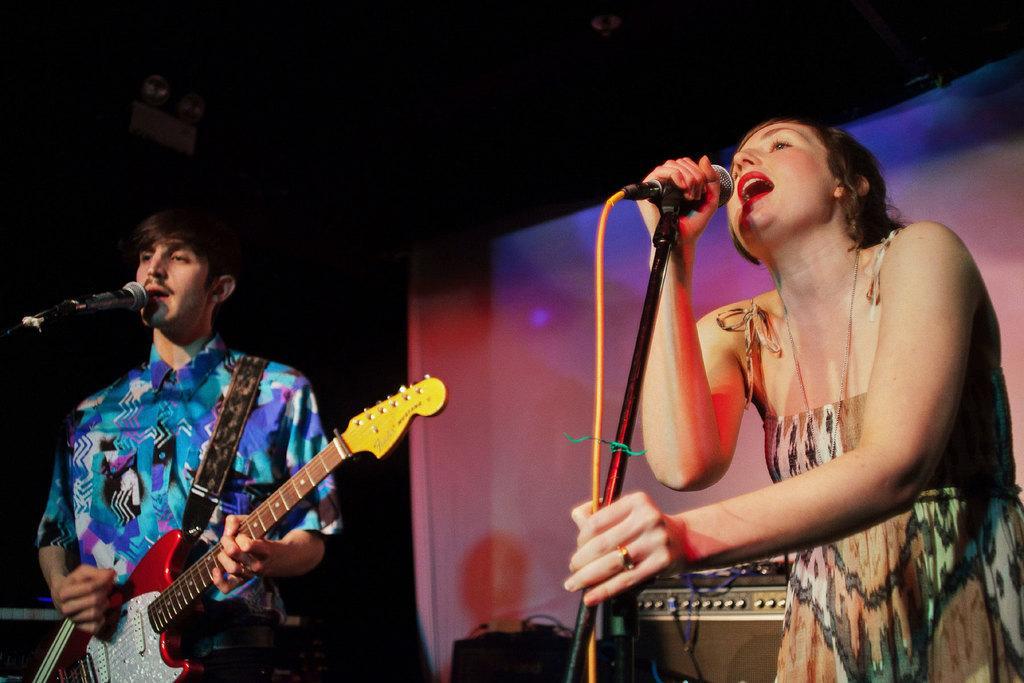Can you describe this image briefly? In this image I see a woman who is standing in front of the mic and I also see a man who is standing in front of a mic and holding the guitar. In the background I see an equipment. 